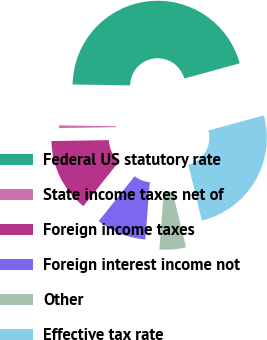Convert chart. <chart><loc_0><loc_0><loc_500><loc_500><pie_chart><fcel>Federal US statutory rate<fcel>State income taxes net of<fcel>Foreign income taxes<fcel>Foreign interest income not<fcel>Other<fcel>Effective tax rate<nl><fcel>45.48%<fcel>0.52%<fcel>14.01%<fcel>9.51%<fcel>5.02%<fcel>25.47%<nl></chart> 